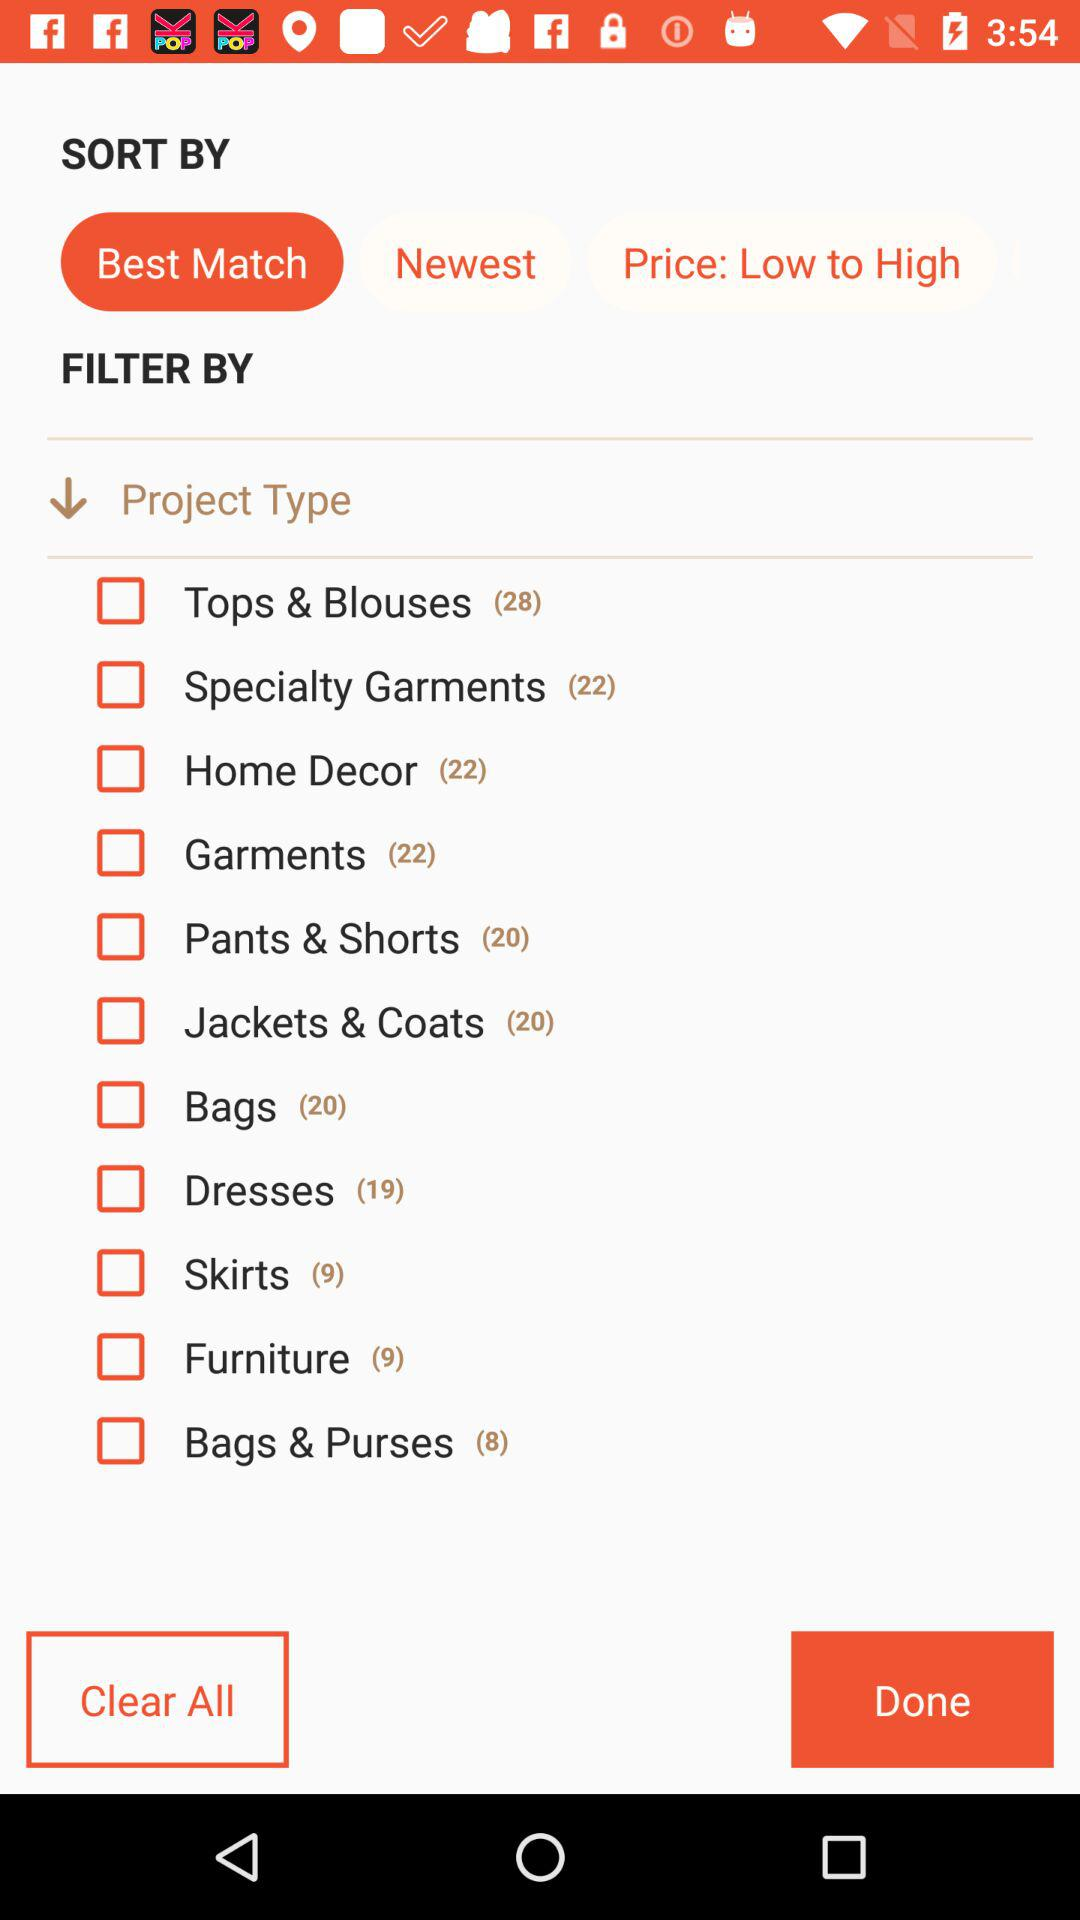How many varieties of dresses are there? There are 19 varieties of dresses. 